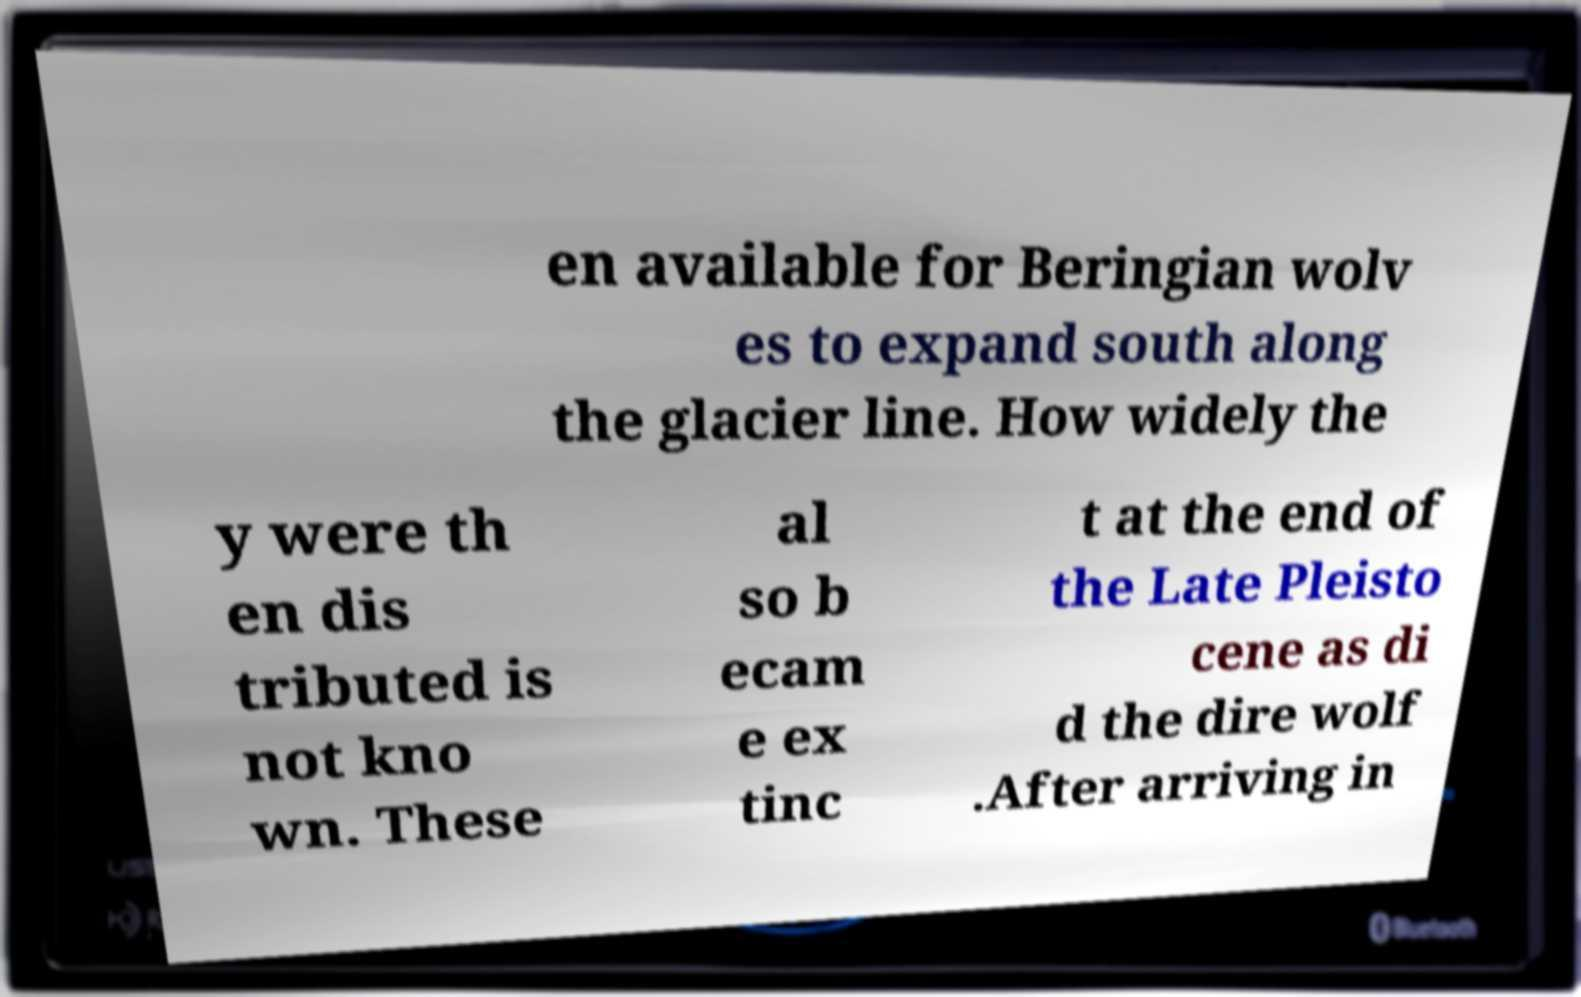For documentation purposes, I need the text within this image transcribed. Could you provide that? en available for Beringian wolv es to expand south along the glacier line. How widely the y were th en dis tributed is not kno wn. These al so b ecam e ex tinc t at the end of the Late Pleisto cene as di d the dire wolf .After arriving in 